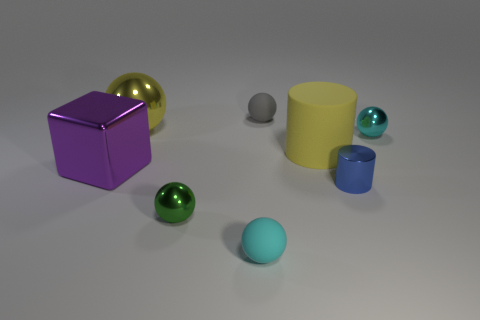Subtract all tiny green shiny balls. How many balls are left? 4 Subtract all green balls. How many balls are left? 4 Subtract all cubes. How many objects are left? 7 Subtract 1 balls. How many balls are left? 4 Subtract all brown cubes. How many blue cylinders are left? 1 Add 6 blue metallic cylinders. How many blue metallic cylinders are left? 7 Add 3 red rubber cylinders. How many red rubber cylinders exist? 3 Add 1 small cyan shiny things. How many objects exist? 9 Subtract 0 purple balls. How many objects are left? 8 Subtract all cyan balls. Subtract all brown blocks. How many balls are left? 3 